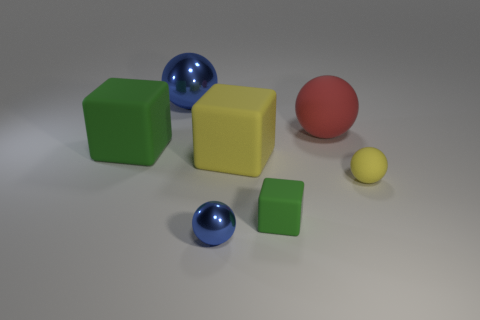The red thing has what shape?
Make the answer very short. Sphere. Are the large sphere that is right of the tiny matte block and the blue thing that is in front of the tiny yellow matte sphere made of the same material?
Give a very brief answer. No. How many small rubber balls are the same color as the big metal sphere?
Provide a succinct answer. 0. There is a object that is both in front of the large red object and to the left of the small blue shiny ball; what shape is it?
Ensure brevity in your answer.  Cube. There is a matte object that is both right of the large metallic sphere and left of the tiny green matte cube; what is its color?
Your response must be concise. Yellow. Is the number of big yellow blocks to the right of the big matte ball greater than the number of big rubber blocks in front of the tiny green rubber thing?
Provide a short and direct response. No. There is a big ball to the right of the small blue metal object; what color is it?
Your answer should be very brief. Red. Does the small matte object on the right side of the small green cube have the same shape as the tiny rubber object that is to the left of the red ball?
Keep it short and to the point. No. Are there any green objects of the same size as the red ball?
Make the answer very short. Yes. There is a tiny ball that is to the left of the yellow cube; what material is it?
Offer a terse response. Metal. 